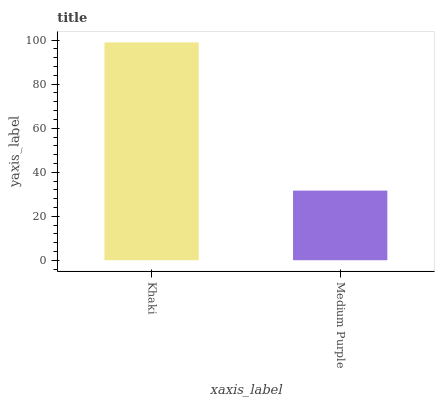Is Medium Purple the minimum?
Answer yes or no. Yes. Is Khaki the maximum?
Answer yes or no. Yes. Is Medium Purple the maximum?
Answer yes or no. No. Is Khaki greater than Medium Purple?
Answer yes or no. Yes. Is Medium Purple less than Khaki?
Answer yes or no. Yes. Is Medium Purple greater than Khaki?
Answer yes or no. No. Is Khaki less than Medium Purple?
Answer yes or no. No. Is Khaki the high median?
Answer yes or no. Yes. Is Medium Purple the low median?
Answer yes or no. Yes. Is Medium Purple the high median?
Answer yes or no. No. Is Khaki the low median?
Answer yes or no. No. 